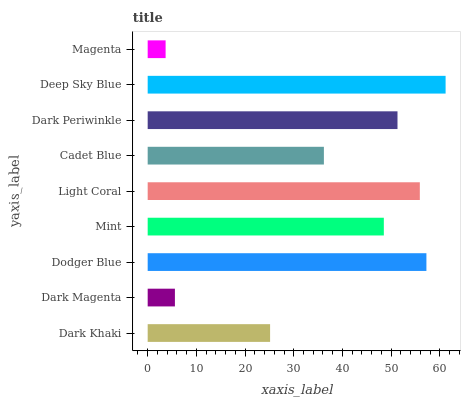Is Magenta the minimum?
Answer yes or no. Yes. Is Deep Sky Blue the maximum?
Answer yes or no. Yes. Is Dark Magenta the minimum?
Answer yes or no. No. Is Dark Magenta the maximum?
Answer yes or no. No. Is Dark Khaki greater than Dark Magenta?
Answer yes or no. Yes. Is Dark Magenta less than Dark Khaki?
Answer yes or no. Yes. Is Dark Magenta greater than Dark Khaki?
Answer yes or no. No. Is Dark Khaki less than Dark Magenta?
Answer yes or no. No. Is Mint the high median?
Answer yes or no. Yes. Is Mint the low median?
Answer yes or no. Yes. Is Deep Sky Blue the high median?
Answer yes or no. No. Is Magenta the low median?
Answer yes or no. No. 